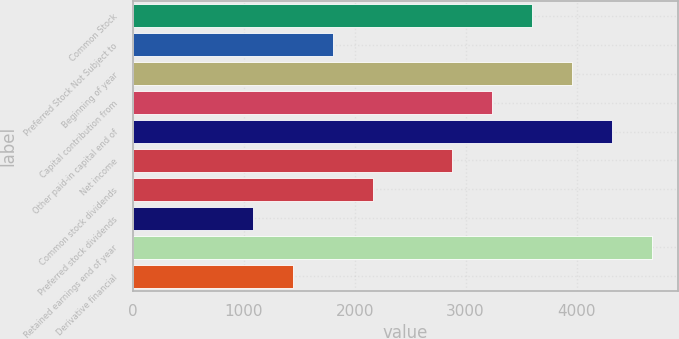Convert chart to OTSL. <chart><loc_0><loc_0><loc_500><loc_500><bar_chart><fcel>Common Stock<fcel>Preferred Stock Not Subject to<fcel>Beginning of year<fcel>Capital contribution from<fcel>Other paid-in capital end of<fcel>Net income<fcel>Common stock dividends<fcel>Preferred stock dividends<fcel>Retained earnings end of year<fcel>Derivative financial<nl><fcel>3601<fcel>1802<fcel>3960.8<fcel>3241.2<fcel>4320.6<fcel>2881.4<fcel>2161.8<fcel>1082.4<fcel>4680.4<fcel>1442.2<nl></chart> 